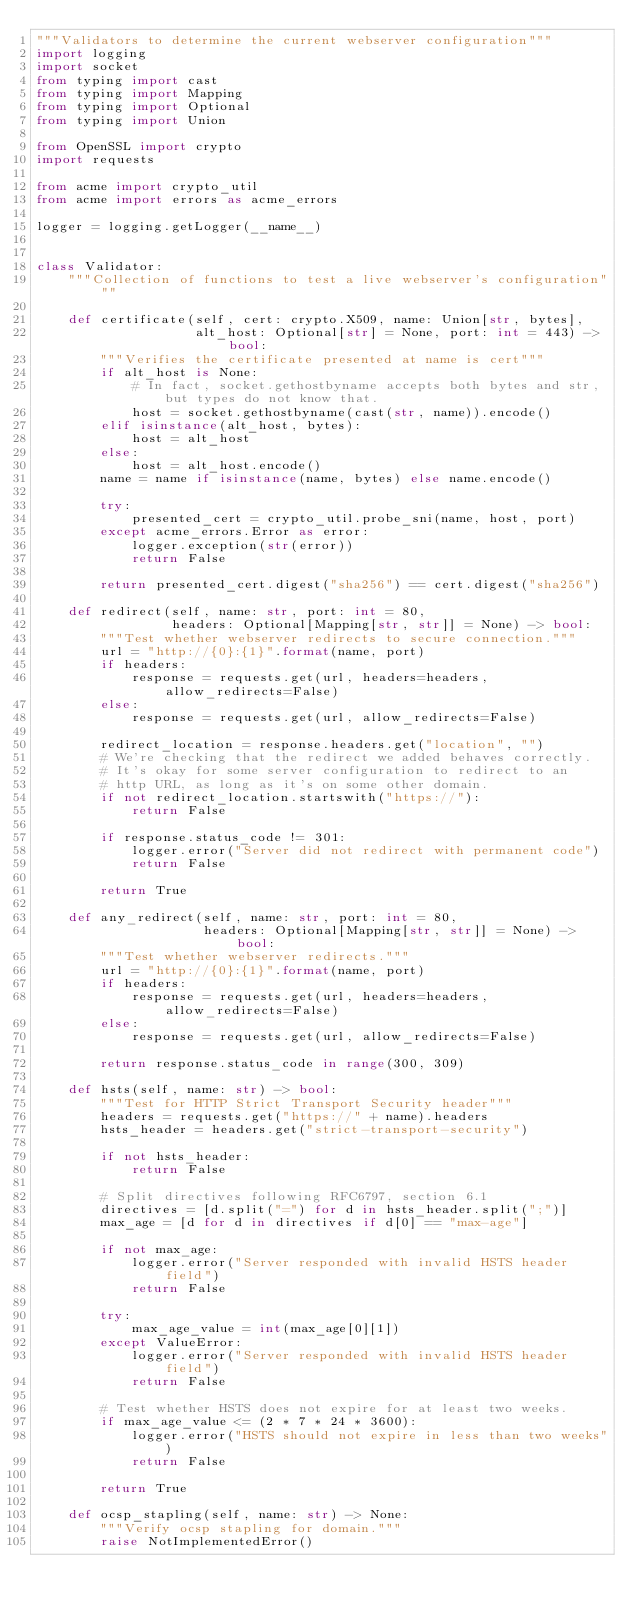<code> <loc_0><loc_0><loc_500><loc_500><_Python_>"""Validators to determine the current webserver configuration"""
import logging
import socket
from typing import cast
from typing import Mapping
from typing import Optional
from typing import Union

from OpenSSL import crypto
import requests

from acme import crypto_util
from acme import errors as acme_errors

logger = logging.getLogger(__name__)


class Validator:
    """Collection of functions to test a live webserver's configuration"""

    def certificate(self, cert: crypto.X509, name: Union[str, bytes],
                    alt_host: Optional[str] = None, port: int = 443) -> bool:
        """Verifies the certificate presented at name is cert"""
        if alt_host is None:
            # In fact, socket.gethostbyname accepts both bytes and str, but types do not know that.
            host = socket.gethostbyname(cast(str, name)).encode()
        elif isinstance(alt_host, bytes):
            host = alt_host
        else:
            host = alt_host.encode()
        name = name if isinstance(name, bytes) else name.encode()

        try:
            presented_cert = crypto_util.probe_sni(name, host, port)
        except acme_errors.Error as error:
            logger.exception(str(error))
            return False

        return presented_cert.digest("sha256") == cert.digest("sha256")

    def redirect(self, name: str, port: int = 80,
                 headers: Optional[Mapping[str, str]] = None) -> bool:
        """Test whether webserver redirects to secure connection."""
        url = "http://{0}:{1}".format(name, port)
        if headers:
            response = requests.get(url, headers=headers, allow_redirects=False)
        else:
            response = requests.get(url, allow_redirects=False)

        redirect_location = response.headers.get("location", "")
        # We're checking that the redirect we added behaves correctly.
        # It's okay for some server configuration to redirect to an
        # http URL, as long as it's on some other domain.
        if not redirect_location.startswith("https://"):
            return False

        if response.status_code != 301:
            logger.error("Server did not redirect with permanent code")
            return False

        return True

    def any_redirect(self, name: str, port: int = 80,
                     headers: Optional[Mapping[str, str]] = None) -> bool:
        """Test whether webserver redirects."""
        url = "http://{0}:{1}".format(name, port)
        if headers:
            response = requests.get(url, headers=headers, allow_redirects=False)
        else:
            response = requests.get(url, allow_redirects=False)

        return response.status_code in range(300, 309)

    def hsts(self, name: str) -> bool:
        """Test for HTTP Strict Transport Security header"""
        headers = requests.get("https://" + name).headers
        hsts_header = headers.get("strict-transport-security")

        if not hsts_header:
            return False

        # Split directives following RFC6797, section 6.1
        directives = [d.split("=") for d in hsts_header.split(";")]
        max_age = [d for d in directives if d[0] == "max-age"]

        if not max_age:
            logger.error("Server responded with invalid HSTS header field")
            return False

        try:
            max_age_value = int(max_age[0][1])
        except ValueError:
            logger.error("Server responded with invalid HSTS header field")
            return False

        # Test whether HSTS does not expire for at least two weeks.
        if max_age_value <= (2 * 7 * 24 * 3600):
            logger.error("HSTS should not expire in less than two weeks")
            return False

        return True

    def ocsp_stapling(self, name: str) -> None:
        """Verify ocsp stapling for domain."""
        raise NotImplementedError()
</code> 